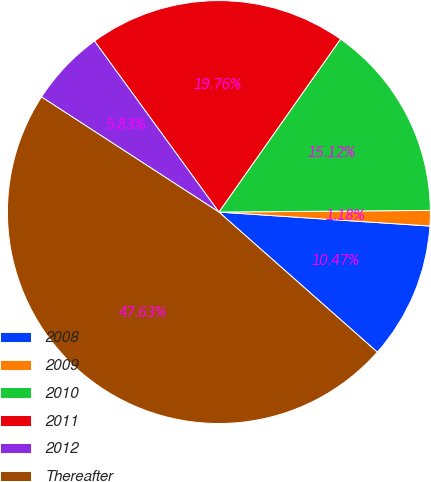<chart> <loc_0><loc_0><loc_500><loc_500><pie_chart><fcel>2008<fcel>2009<fcel>2010<fcel>2011<fcel>2012<fcel>Thereafter<nl><fcel>10.47%<fcel>1.18%<fcel>15.12%<fcel>19.76%<fcel>5.83%<fcel>47.63%<nl></chart> 